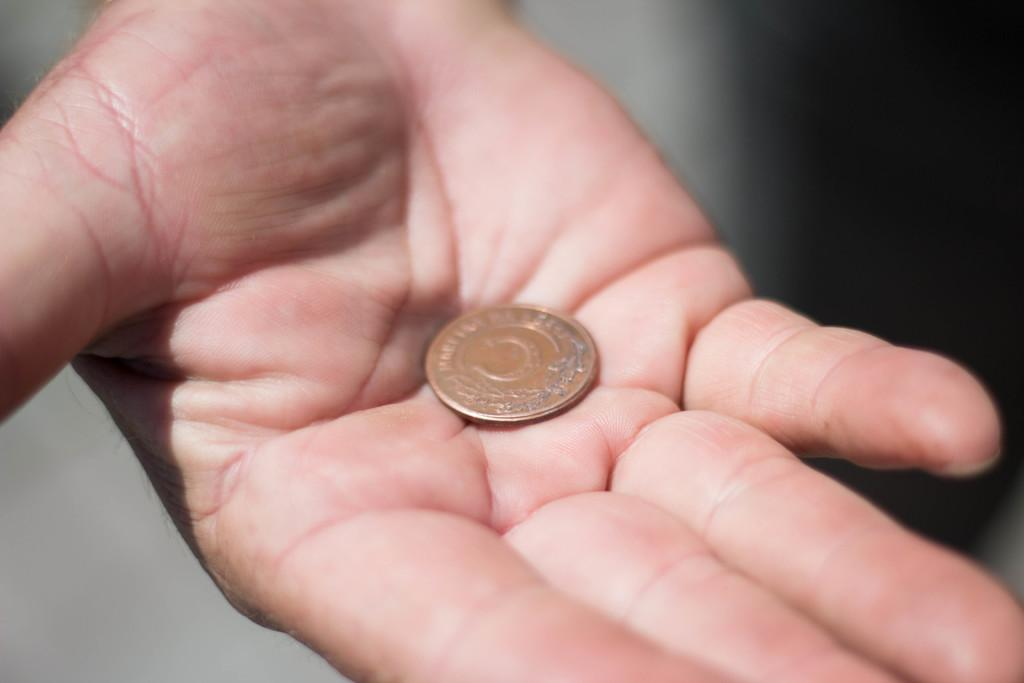What object is in the image? There is a coin in the image. Where is the coin located? The coin is on a person's hand. Can you describe the background of the image? The background of the image is blurry. How many women are visible in the image? There is no mention of women in the provided facts, so it cannot be determined from the image. What type of tax is being discussed in the image? There is no mention of tax in the provided facts, so it cannot be determined from the image. 